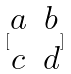<formula> <loc_0><loc_0><loc_500><loc_500>[ \begin{matrix} a & b \\ c & d \\ \end{matrix} ]</formula> 